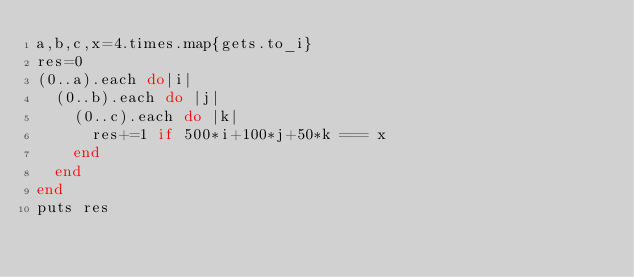<code> <loc_0><loc_0><loc_500><loc_500><_Ruby_>a,b,c,x=4.times.map{gets.to_i}
res=0
(0..a).each do|i|
  (0..b).each do |j|
    (0..c).each do |k|
      res+=1 if 500*i+100*j+50*k === x
    end
  end
end
puts res</code> 